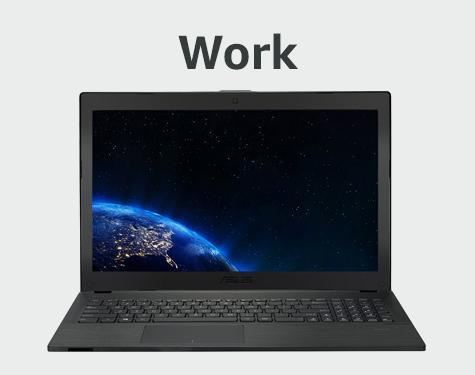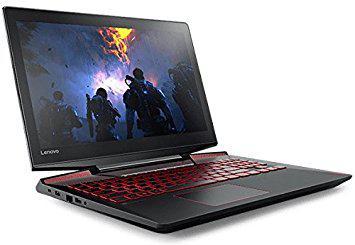The first image is the image on the left, the second image is the image on the right. Assess this claim about the two images: "In one image there is a laptop computer from the brand hp and the other image has a DELL laptop.". Correct or not? Answer yes or no. No. The first image is the image on the left, the second image is the image on the right. Given the left and right images, does the statement "There is one laptop shown front and back." hold true? Answer yes or no. No. 